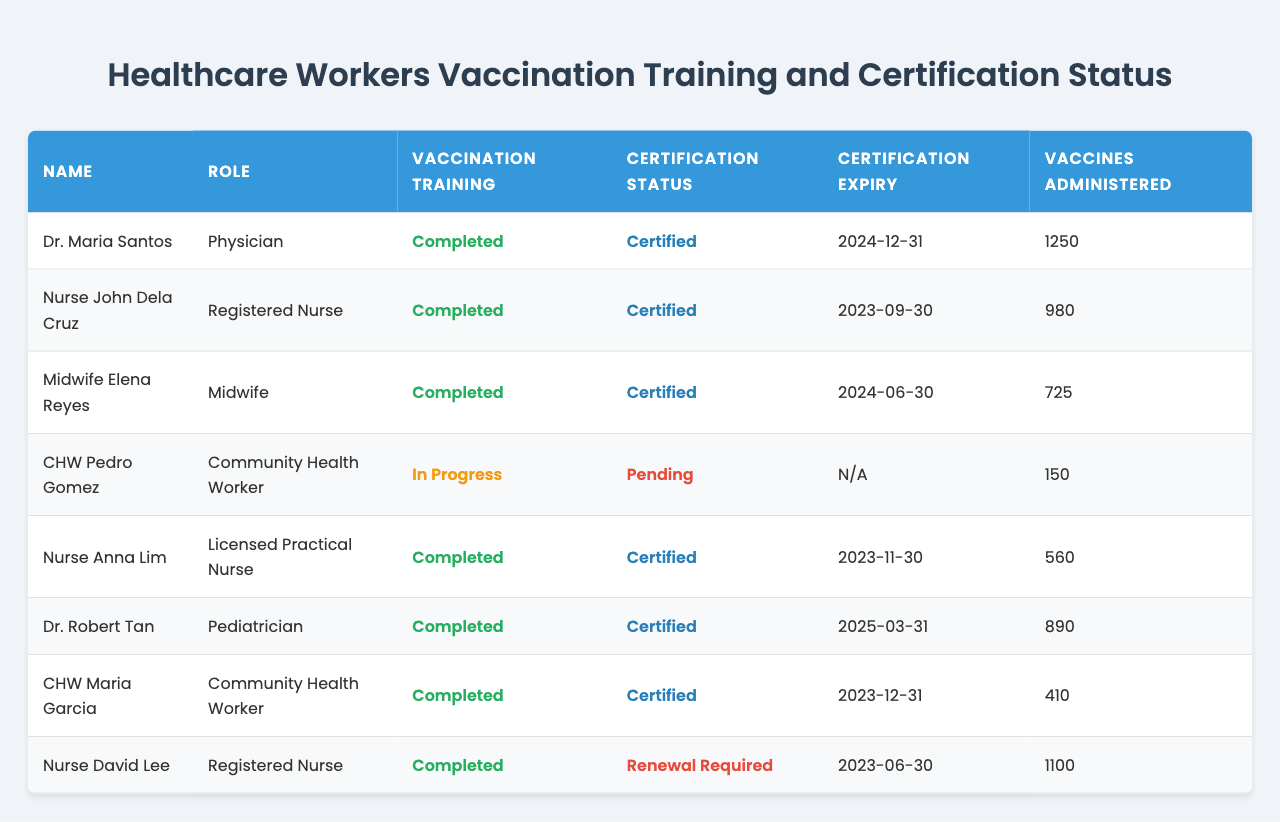What is the name of the healthcare worker with the highest number of vaccines administered? I will look through the table and identify the "vaccines administered" column. Dr. Maria Santos has administered 1250 vaccines, which is the highest among the listed healthcare workers.
Answer: Dr. Maria Santos How many healthcare workers have completed their vaccination training? By counting the rows under the "Vaccination Training" column marked as "Completed," I can see that there are six healthcare workers with completed vaccination training.
Answer: 6 Who has the certification status that requires renewal? I can check the "Certification Status" column for any entries labeled "Renewal Required." Nurse David Lee is the only healthcare worker with this status.
Answer: Nurse David Lee What is the total number of vaccines administered by all healthcare workers listed? To find the total, I'll sum the "Vaccines Administered" values: 1250 + 980 + 725 + 150 + 560 + 890 + 410 + 1100 = 5155.
Answer: 5155 Is there a healthcare worker whose certification is both pending and has vaccination training in progress? I will look for a worker with "Pending" certification status and "In Progress" vaccination training. CHW Pedro Gomez meets both criteria.
Answer: Yes What is the average number of vaccines administered by the certified healthcare workers? I'll first identify the certified workers: Dr. Maria Santos, Nurse John Dela Cruz, Midwife Elena Reyes, Nurse Anna Lim, Dr. Robert Tan, and CHW Maria Garcia. Their vaccine totals are 1250, 980, 725, 560, 890, and 410. The total is 4755, and there are six certified healthcare workers, so the average is 4755/6 = 792.5.
Answer: 792.5 Which healthcare worker has the earliest certification expiry date? I will look at the "Certification Expiry" dates and compare them. Nurse John Dela Cruz has a certification expiry of 2023-09-30, which is the earliest date among all workers.
Answer: Nurse John Dela Cruz What percentage of healthcare workers are certified out of those listed? There are eight healthcare workers in total. Six of them are certified. To find the percentage, I calculate (6/8) * 100, which equals 75%.
Answer: 75% 